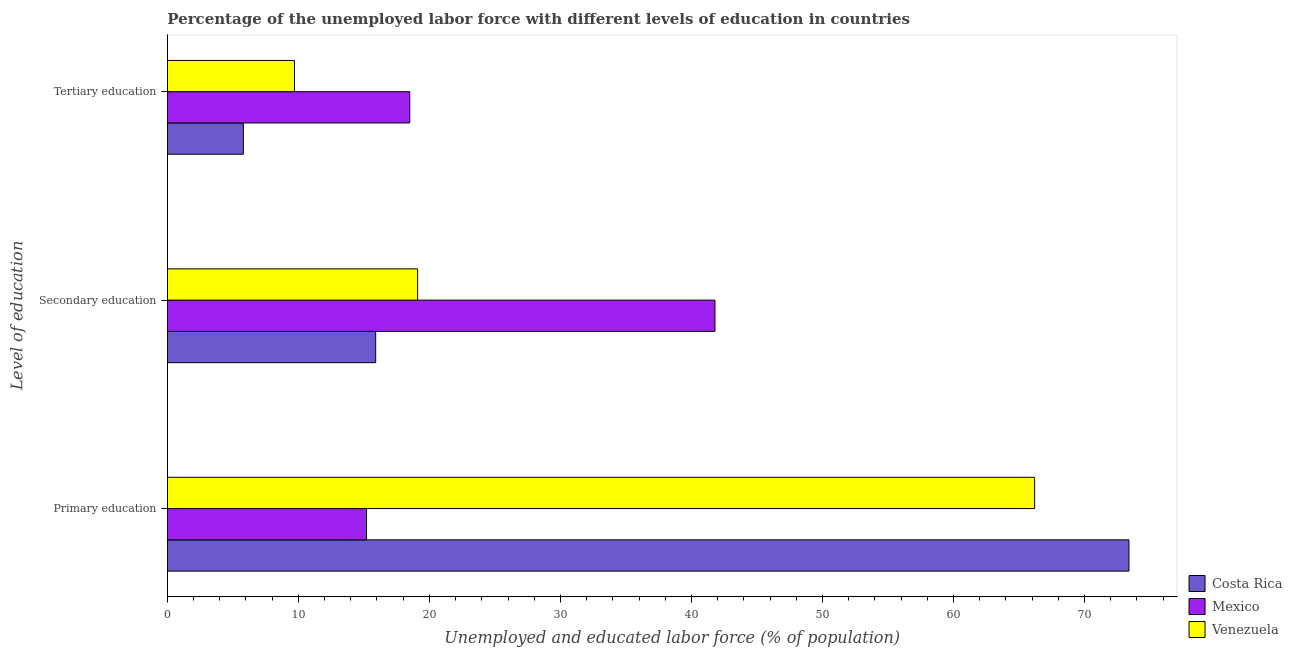Are the number of bars per tick equal to the number of legend labels?
Your response must be concise. Yes. How many bars are there on the 1st tick from the top?
Keep it short and to the point. 3. How many bars are there on the 3rd tick from the bottom?
Your answer should be compact. 3. What is the label of the 2nd group of bars from the top?
Make the answer very short. Secondary education. What is the percentage of labor force who received primary education in Venezuela?
Offer a very short reply. 66.2. Across all countries, what is the maximum percentage of labor force who received tertiary education?
Ensure brevity in your answer.  18.5. Across all countries, what is the minimum percentage of labor force who received secondary education?
Give a very brief answer. 15.9. In which country was the percentage of labor force who received tertiary education minimum?
Keep it short and to the point. Costa Rica. What is the total percentage of labor force who received primary education in the graph?
Offer a very short reply. 154.8. What is the difference between the percentage of labor force who received tertiary education in Venezuela and that in Mexico?
Provide a short and direct response. -8.8. What is the difference between the percentage of labor force who received secondary education in Venezuela and the percentage of labor force who received primary education in Mexico?
Give a very brief answer. 3.9. What is the average percentage of labor force who received secondary education per country?
Provide a short and direct response. 25.6. What is the difference between the percentage of labor force who received tertiary education and percentage of labor force who received primary education in Venezuela?
Offer a terse response. -56.5. In how many countries, is the percentage of labor force who received secondary education greater than 58 %?
Give a very brief answer. 0. What is the ratio of the percentage of labor force who received secondary education in Costa Rica to that in Venezuela?
Provide a succinct answer. 0.83. Is the difference between the percentage of labor force who received tertiary education in Costa Rica and Mexico greater than the difference between the percentage of labor force who received primary education in Costa Rica and Mexico?
Keep it short and to the point. No. What is the difference between the highest and the second highest percentage of labor force who received primary education?
Give a very brief answer. 7.2. What is the difference between the highest and the lowest percentage of labor force who received tertiary education?
Provide a succinct answer. 12.7. In how many countries, is the percentage of labor force who received secondary education greater than the average percentage of labor force who received secondary education taken over all countries?
Ensure brevity in your answer.  1. Is the sum of the percentage of labor force who received secondary education in Costa Rica and Venezuela greater than the maximum percentage of labor force who received primary education across all countries?
Your response must be concise. No. What does the 1st bar from the top in Secondary education represents?
Provide a short and direct response. Venezuela. What does the 1st bar from the bottom in Primary education represents?
Make the answer very short. Costa Rica. How many bars are there?
Your response must be concise. 9. How many countries are there in the graph?
Your response must be concise. 3. What is the difference between two consecutive major ticks on the X-axis?
Your answer should be compact. 10. Are the values on the major ticks of X-axis written in scientific E-notation?
Ensure brevity in your answer.  No. Does the graph contain any zero values?
Provide a succinct answer. No. Does the graph contain grids?
Offer a very short reply. No. Where does the legend appear in the graph?
Ensure brevity in your answer.  Bottom right. What is the title of the graph?
Keep it short and to the point. Percentage of the unemployed labor force with different levels of education in countries. What is the label or title of the X-axis?
Give a very brief answer. Unemployed and educated labor force (% of population). What is the label or title of the Y-axis?
Offer a very short reply. Level of education. What is the Unemployed and educated labor force (% of population) of Costa Rica in Primary education?
Offer a terse response. 73.4. What is the Unemployed and educated labor force (% of population) of Mexico in Primary education?
Offer a very short reply. 15.2. What is the Unemployed and educated labor force (% of population) in Venezuela in Primary education?
Provide a short and direct response. 66.2. What is the Unemployed and educated labor force (% of population) in Costa Rica in Secondary education?
Give a very brief answer. 15.9. What is the Unemployed and educated labor force (% of population) in Mexico in Secondary education?
Provide a succinct answer. 41.8. What is the Unemployed and educated labor force (% of population) of Venezuela in Secondary education?
Your response must be concise. 19.1. What is the Unemployed and educated labor force (% of population) in Costa Rica in Tertiary education?
Give a very brief answer. 5.8. What is the Unemployed and educated labor force (% of population) in Mexico in Tertiary education?
Ensure brevity in your answer.  18.5. What is the Unemployed and educated labor force (% of population) of Venezuela in Tertiary education?
Your answer should be compact. 9.7. Across all Level of education, what is the maximum Unemployed and educated labor force (% of population) of Costa Rica?
Ensure brevity in your answer.  73.4. Across all Level of education, what is the maximum Unemployed and educated labor force (% of population) of Mexico?
Offer a terse response. 41.8. Across all Level of education, what is the maximum Unemployed and educated labor force (% of population) of Venezuela?
Provide a short and direct response. 66.2. Across all Level of education, what is the minimum Unemployed and educated labor force (% of population) in Costa Rica?
Ensure brevity in your answer.  5.8. Across all Level of education, what is the minimum Unemployed and educated labor force (% of population) of Mexico?
Offer a very short reply. 15.2. Across all Level of education, what is the minimum Unemployed and educated labor force (% of population) of Venezuela?
Ensure brevity in your answer.  9.7. What is the total Unemployed and educated labor force (% of population) of Costa Rica in the graph?
Provide a short and direct response. 95.1. What is the total Unemployed and educated labor force (% of population) of Mexico in the graph?
Your answer should be compact. 75.5. What is the total Unemployed and educated labor force (% of population) in Venezuela in the graph?
Your response must be concise. 95. What is the difference between the Unemployed and educated labor force (% of population) of Costa Rica in Primary education and that in Secondary education?
Your response must be concise. 57.5. What is the difference between the Unemployed and educated labor force (% of population) of Mexico in Primary education and that in Secondary education?
Ensure brevity in your answer.  -26.6. What is the difference between the Unemployed and educated labor force (% of population) in Venezuela in Primary education and that in Secondary education?
Provide a short and direct response. 47.1. What is the difference between the Unemployed and educated labor force (% of population) in Costa Rica in Primary education and that in Tertiary education?
Keep it short and to the point. 67.6. What is the difference between the Unemployed and educated labor force (% of population) of Venezuela in Primary education and that in Tertiary education?
Make the answer very short. 56.5. What is the difference between the Unemployed and educated labor force (% of population) in Mexico in Secondary education and that in Tertiary education?
Make the answer very short. 23.3. What is the difference between the Unemployed and educated labor force (% of population) in Venezuela in Secondary education and that in Tertiary education?
Make the answer very short. 9.4. What is the difference between the Unemployed and educated labor force (% of population) in Costa Rica in Primary education and the Unemployed and educated labor force (% of population) in Mexico in Secondary education?
Ensure brevity in your answer.  31.6. What is the difference between the Unemployed and educated labor force (% of population) in Costa Rica in Primary education and the Unemployed and educated labor force (% of population) in Venezuela in Secondary education?
Make the answer very short. 54.3. What is the difference between the Unemployed and educated labor force (% of population) of Mexico in Primary education and the Unemployed and educated labor force (% of population) of Venezuela in Secondary education?
Provide a succinct answer. -3.9. What is the difference between the Unemployed and educated labor force (% of population) of Costa Rica in Primary education and the Unemployed and educated labor force (% of population) of Mexico in Tertiary education?
Make the answer very short. 54.9. What is the difference between the Unemployed and educated labor force (% of population) in Costa Rica in Primary education and the Unemployed and educated labor force (% of population) in Venezuela in Tertiary education?
Offer a very short reply. 63.7. What is the difference between the Unemployed and educated labor force (% of population) in Costa Rica in Secondary education and the Unemployed and educated labor force (% of population) in Mexico in Tertiary education?
Keep it short and to the point. -2.6. What is the difference between the Unemployed and educated labor force (% of population) in Costa Rica in Secondary education and the Unemployed and educated labor force (% of population) in Venezuela in Tertiary education?
Provide a succinct answer. 6.2. What is the difference between the Unemployed and educated labor force (% of population) of Mexico in Secondary education and the Unemployed and educated labor force (% of population) of Venezuela in Tertiary education?
Your answer should be very brief. 32.1. What is the average Unemployed and educated labor force (% of population) in Costa Rica per Level of education?
Offer a terse response. 31.7. What is the average Unemployed and educated labor force (% of population) in Mexico per Level of education?
Give a very brief answer. 25.17. What is the average Unemployed and educated labor force (% of population) of Venezuela per Level of education?
Offer a very short reply. 31.67. What is the difference between the Unemployed and educated labor force (% of population) of Costa Rica and Unemployed and educated labor force (% of population) of Mexico in Primary education?
Offer a terse response. 58.2. What is the difference between the Unemployed and educated labor force (% of population) of Mexico and Unemployed and educated labor force (% of population) of Venezuela in Primary education?
Your answer should be compact. -51. What is the difference between the Unemployed and educated labor force (% of population) of Costa Rica and Unemployed and educated labor force (% of population) of Mexico in Secondary education?
Offer a very short reply. -25.9. What is the difference between the Unemployed and educated labor force (% of population) in Mexico and Unemployed and educated labor force (% of population) in Venezuela in Secondary education?
Your answer should be compact. 22.7. What is the difference between the Unemployed and educated labor force (% of population) of Costa Rica and Unemployed and educated labor force (% of population) of Venezuela in Tertiary education?
Provide a short and direct response. -3.9. What is the difference between the Unemployed and educated labor force (% of population) of Mexico and Unemployed and educated labor force (% of population) of Venezuela in Tertiary education?
Offer a terse response. 8.8. What is the ratio of the Unemployed and educated labor force (% of population) of Costa Rica in Primary education to that in Secondary education?
Your response must be concise. 4.62. What is the ratio of the Unemployed and educated labor force (% of population) of Mexico in Primary education to that in Secondary education?
Provide a succinct answer. 0.36. What is the ratio of the Unemployed and educated labor force (% of population) of Venezuela in Primary education to that in Secondary education?
Your response must be concise. 3.47. What is the ratio of the Unemployed and educated labor force (% of population) of Costa Rica in Primary education to that in Tertiary education?
Your answer should be compact. 12.66. What is the ratio of the Unemployed and educated labor force (% of population) in Mexico in Primary education to that in Tertiary education?
Ensure brevity in your answer.  0.82. What is the ratio of the Unemployed and educated labor force (% of population) in Venezuela in Primary education to that in Tertiary education?
Keep it short and to the point. 6.82. What is the ratio of the Unemployed and educated labor force (% of population) in Costa Rica in Secondary education to that in Tertiary education?
Offer a terse response. 2.74. What is the ratio of the Unemployed and educated labor force (% of population) in Mexico in Secondary education to that in Tertiary education?
Your answer should be very brief. 2.26. What is the ratio of the Unemployed and educated labor force (% of population) of Venezuela in Secondary education to that in Tertiary education?
Your answer should be very brief. 1.97. What is the difference between the highest and the second highest Unemployed and educated labor force (% of population) in Costa Rica?
Your answer should be compact. 57.5. What is the difference between the highest and the second highest Unemployed and educated labor force (% of population) in Mexico?
Provide a short and direct response. 23.3. What is the difference between the highest and the second highest Unemployed and educated labor force (% of population) in Venezuela?
Your response must be concise. 47.1. What is the difference between the highest and the lowest Unemployed and educated labor force (% of population) in Costa Rica?
Your answer should be very brief. 67.6. What is the difference between the highest and the lowest Unemployed and educated labor force (% of population) in Mexico?
Give a very brief answer. 26.6. What is the difference between the highest and the lowest Unemployed and educated labor force (% of population) in Venezuela?
Offer a very short reply. 56.5. 